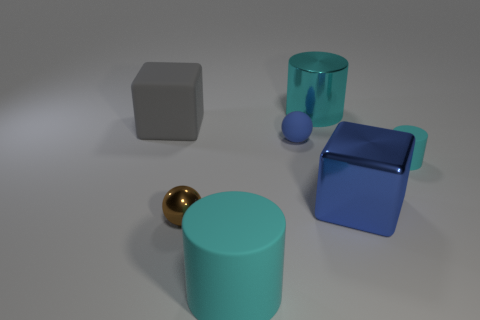Subtract all big cylinders. How many cylinders are left? 1 Add 1 big cyan cylinders. How many objects exist? 8 Subtract all gray cubes. How many cubes are left? 1 Subtract all cylinders. How many objects are left? 4 Subtract 0 brown cylinders. How many objects are left? 7 Subtract 1 cubes. How many cubes are left? 1 Subtract all yellow cylinders. Subtract all blue balls. How many cylinders are left? 3 Subtract all large cyan metal objects. Subtract all big cyan cylinders. How many objects are left? 4 Add 5 brown shiny balls. How many brown shiny balls are left? 6 Add 1 small rubber objects. How many small rubber objects exist? 3 